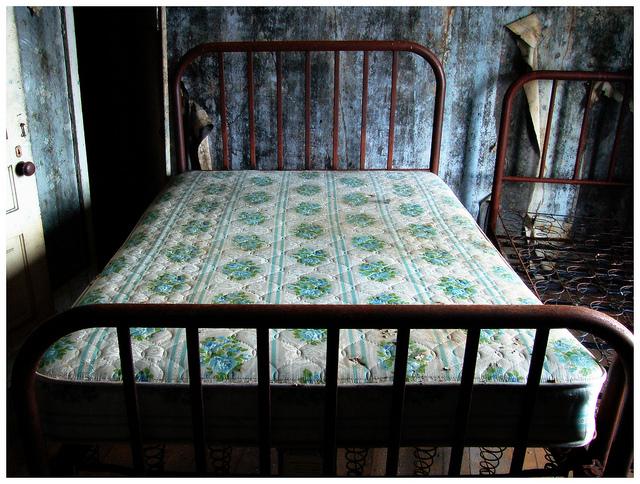What color is the mattress?
Answer briefly. White and green. Is the room dirty?
Write a very short answer. Yes. Is the wall clean?
Keep it brief. No. 